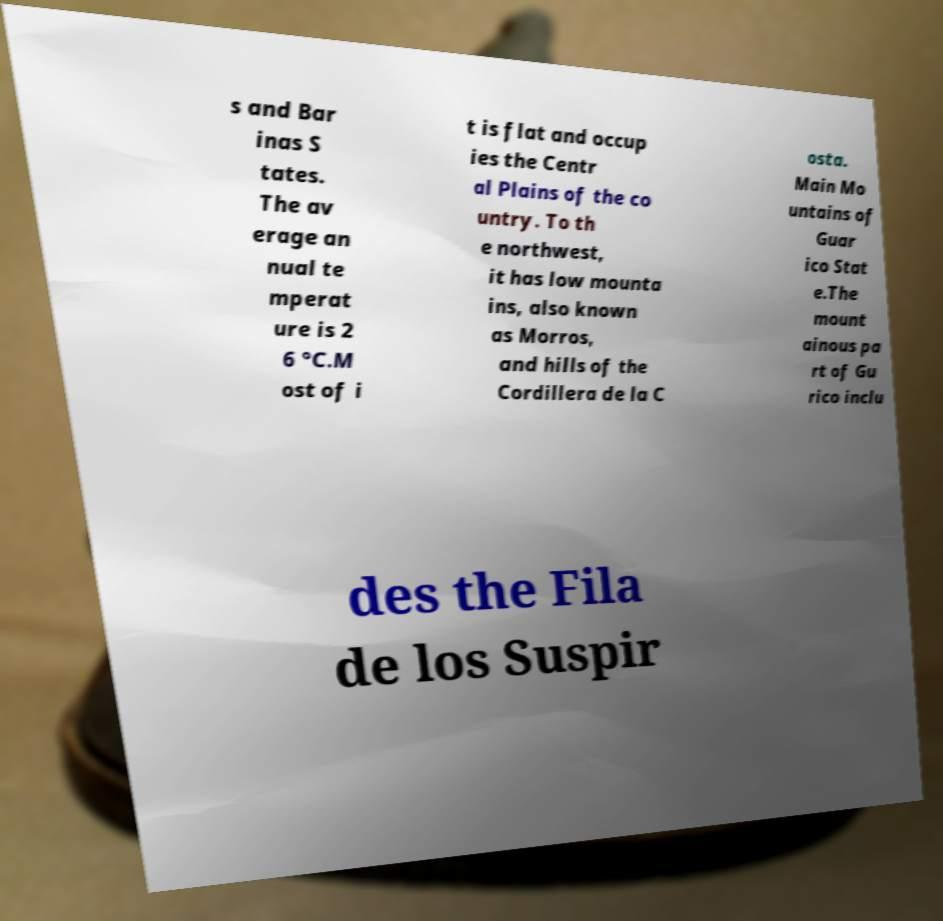I need the written content from this picture converted into text. Can you do that? s and Bar inas S tates. The av erage an nual te mperat ure is 2 6 °C.M ost of i t is flat and occup ies the Centr al Plains of the co untry. To th e northwest, it has low mounta ins, also known as Morros, and hills of the Cordillera de la C osta. Main Mo untains of Guar ico Stat e.The mount ainous pa rt of Gu rico inclu des the Fila de los Suspir 